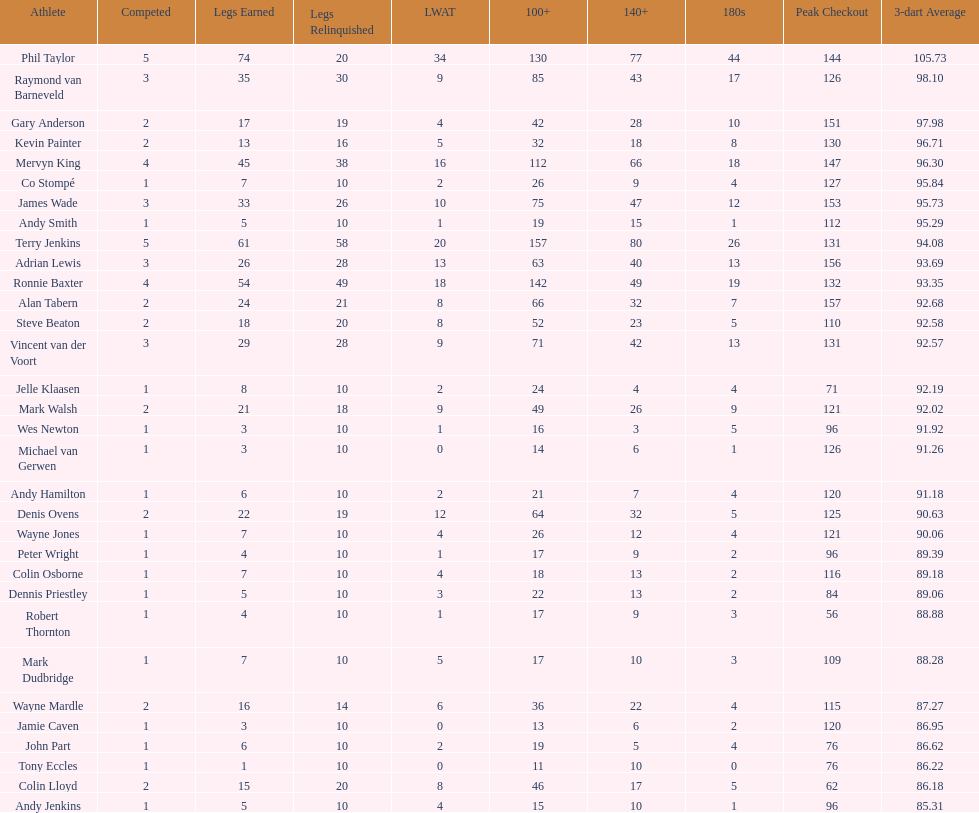Write the full table. {'header': ['Athlete', 'Competed', 'Legs Earned', 'Legs Relinquished', 'LWAT', '100+', '140+', '180s', 'Peak Checkout', '3-dart Average'], 'rows': [['Phil Taylor', '5', '74', '20', '34', '130', '77', '44', '144', '105.73'], ['Raymond van Barneveld', '3', '35', '30', '9', '85', '43', '17', '126', '98.10'], ['Gary Anderson', '2', '17', '19', '4', '42', '28', '10', '151', '97.98'], ['Kevin Painter', '2', '13', '16', '5', '32', '18', '8', '130', '96.71'], ['Mervyn King', '4', '45', '38', '16', '112', '66', '18', '147', '96.30'], ['Co Stompé', '1', '7', '10', '2', '26', '9', '4', '127', '95.84'], ['James Wade', '3', '33', '26', '10', '75', '47', '12', '153', '95.73'], ['Andy Smith', '1', '5', '10', '1', '19', '15', '1', '112', '95.29'], ['Terry Jenkins', '5', '61', '58', '20', '157', '80', '26', '131', '94.08'], ['Adrian Lewis', '3', '26', '28', '13', '63', '40', '13', '156', '93.69'], ['Ronnie Baxter', '4', '54', '49', '18', '142', '49', '19', '132', '93.35'], ['Alan Tabern', '2', '24', '21', '8', '66', '32', '7', '157', '92.68'], ['Steve Beaton', '2', '18', '20', '8', '52', '23', '5', '110', '92.58'], ['Vincent van der Voort', '3', '29', '28', '9', '71', '42', '13', '131', '92.57'], ['Jelle Klaasen', '1', '8', '10', '2', '24', '4', '4', '71', '92.19'], ['Mark Walsh', '2', '21', '18', '9', '49', '26', '9', '121', '92.02'], ['Wes Newton', '1', '3', '10', '1', '16', '3', '5', '96', '91.92'], ['Michael van Gerwen', '1', '3', '10', '0', '14', '6', '1', '126', '91.26'], ['Andy Hamilton', '1', '6', '10', '2', '21', '7', '4', '120', '91.18'], ['Denis Ovens', '2', '22', '19', '12', '64', '32', '5', '125', '90.63'], ['Wayne Jones', '1', '7', '10', '4', '26', '12', '4', '121', '90.06'], ['Peter Wright', '1', '4', '10', '1', '17', '9', '2', '96', '89.39'], ['Colin Osborne', '1', '7', '10', '4', '18', '13', '2', '116', '89.18'], ['Dennis Priestley', '1', '5', '10', '3', '22', '13', '2', '84', '89.06'], ['Robert Thornton', '1', '4', '10', '1', '17', '9', '3', '56', '88.88'], ['Mark Dudbridge', '1', '7', '10', '5', '17', '10', '3', '109', '88.28'], ['Wayne Mardle', '2', '16', '14', '6', '36', '22', '4', '115', '87.27'], ['Jamie Caven', '1', '3', '10', '0', '13', '6', '2', '120', '86.95'], ['John Part', '1', '6', '10', '2', '19', '5', '4', '76', '86.62'], ['Tony Eccles', '1', '1', '10', '0', '11', '10', '0', '76', '86.22'], ['Colin Lloyd', '2', '15', '20', '8', '46', '17', '5', '62', '86.18'], ['Andy Jenkins', '1', '5', '10', '4', '15', '10', '1', '96', '85.31']]} Who claimed the most legs in the 2009 world matchplay? Phil Taylor. 